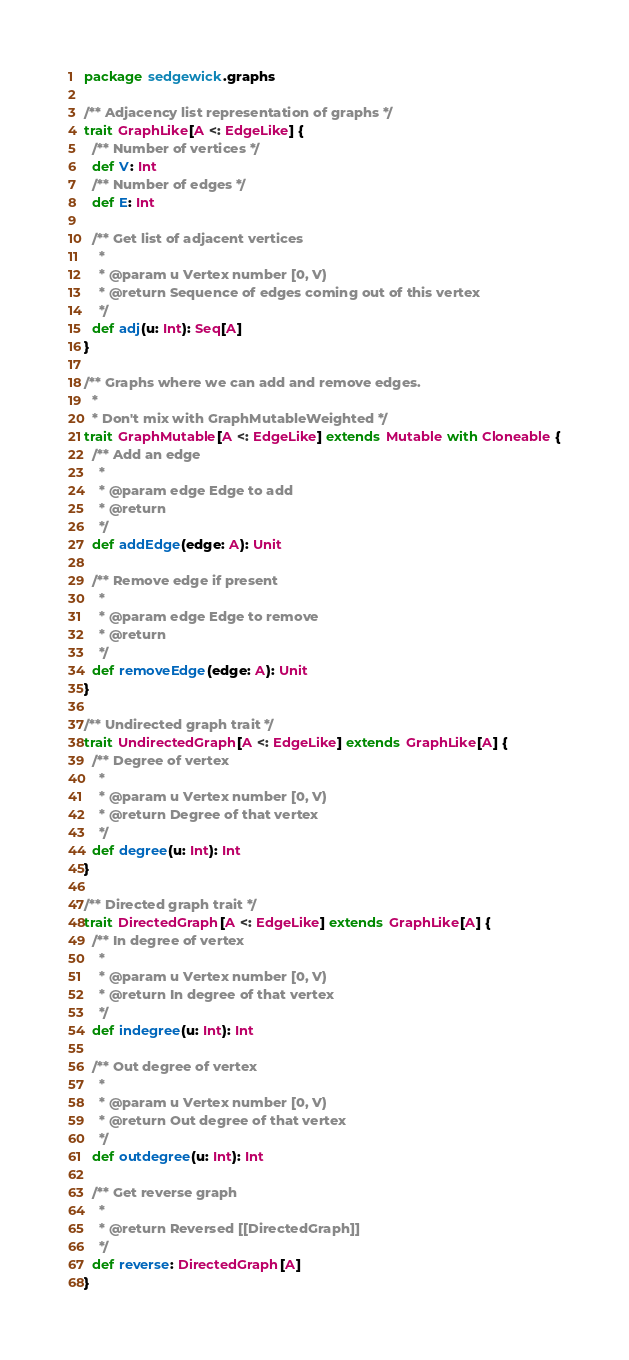<code> <loc_0><loc_0><loc_500><loc_500><_Scala_>package sedgewick.graphs

/** Adjacency list representation of graphs */
trait GraphLike[A <: EdgeLike] {
  /** Number of vertices */
  def V: Int
  /** Number of edges */
  def E: Int

  /** Get list of adjacent vertices
    *
    * @param u Vertex number [0, V)
    * @return Sequence of edges coming out of this vertex
    */
  def adj(u: Int): Seq[A]
}

/** Graphs where we can add and remove edges.
  *
  * Don't mix with GraphMutableWeighted */
trait GraphMutable[A <: EdgeLike] extends Mutable with Cloneable {
  /** Add an edge
    *
    * @param edge Edge to add
    * @return
    */
  def addEdge(edge: A): Unit

  /** Remove edge if present
    *
    * @param edge Edge to remove
    * @return
    */
  def removeEdge(edge: A): Unit
}

/** Undirected graph trait */
trait UndirectedGraph[A <: EdgeLike] extends GraphLike[A] {
  /** Degree of vertex
    *
    * @param u Vertex number [0, V)
    * @return Degree of that vertex
    */
  def degree(u: Int): Int
}

/** Directed graph trait */
trait DirectedGraph[A <: EdgeLike] extends GraphLike[A] {
  /** In degree of vertex
    *
    * @param u Vertex number [0, V)
    * @return In degree of that vertex
    */
  def indegree(u: Int): Int

  /** Out degree of vertex
    *
    * @param u Vertex number [0, V)
    * @return Out degree of that vertex
    */
  def outdegree(u: Int): Int

  /** Get reverse graph
    *
    * @return Reversed [[DirectedGraph]]
    */
  def reverse: DirectedGraph[A]
}</code> 